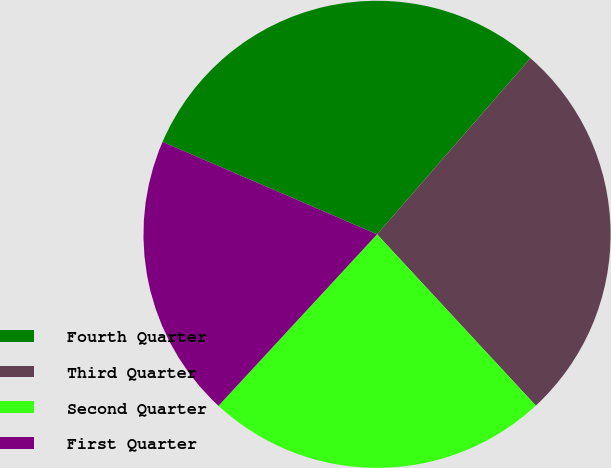Convert chart. <chart><loc_0><loc_0><loc_500><loc_500><pie_chart><fcel>Fourth Quarter<fcel>Third Quarter<fcel>Second Quarter<fcel>First Quarter<nl><fcel>29.92%<fcel>26.7%<fcel>23.77%<fcel>19.6%<nl></chart> 